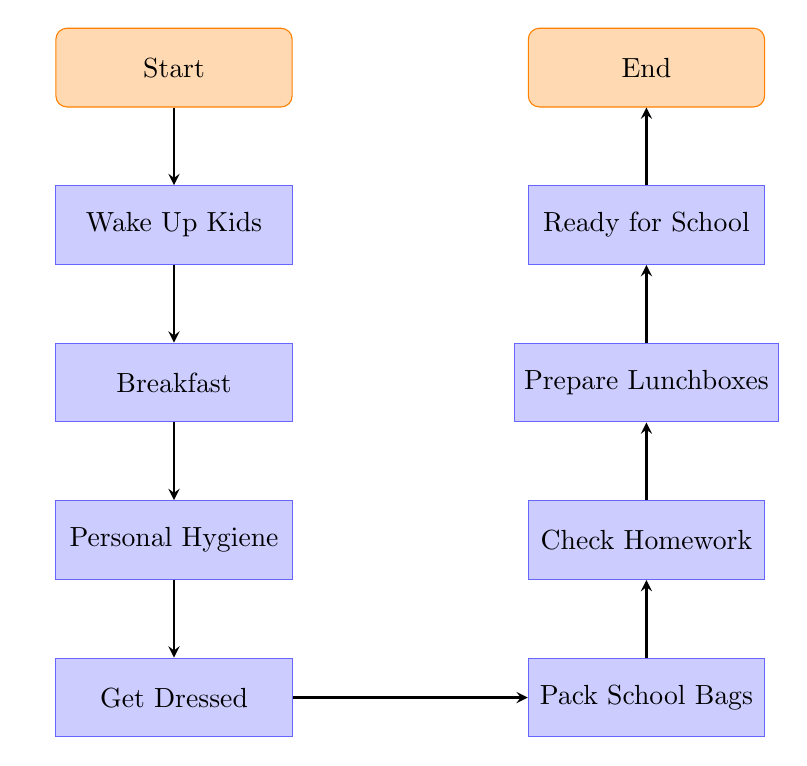What is the first step in the process? The first node in the diagram represents the initial action to take, which is "Wake Up Kids."
Answer: Wake Up Kids How many total steps are in the preparation process? By counting the nodes from "Wake Up Kids" to "Ready for School," there are eight steps in total, including the starting and ending nodes.
Answer: Eight What should be done after "Breakfast"? Following "Breakfast," the next action according to the diagram is "Personal Hygiene."
Answer: Personal Hygiene Which step involves packing lunches? The diagram indicates that "Prepare Lunchboxes" is the step where packing healthy lunches occurs.
Answer: Prepare Lunchboxes After packing school bags, what is the next step? The flow chart shows that after "Pack School Bags," the next action to take is "Check Homework."
Answer: Check Homework What is the last action before the kids are ready for school? The final step indicated before the kids are ready to leave for school is "Ready for School."
Answer: Ready for School If a child completes their homework, which step comes right after? After completing homework, the next step according to the diagram is "Prepare Lunchboxes."
Answer: Prepare Lunchboxes What items do you pack in the step before "Ready for School"? Just before the "Ready for School" step, the items packed are "Prepare Lunchboxes."
Answer: Prepare Lunchboxes 